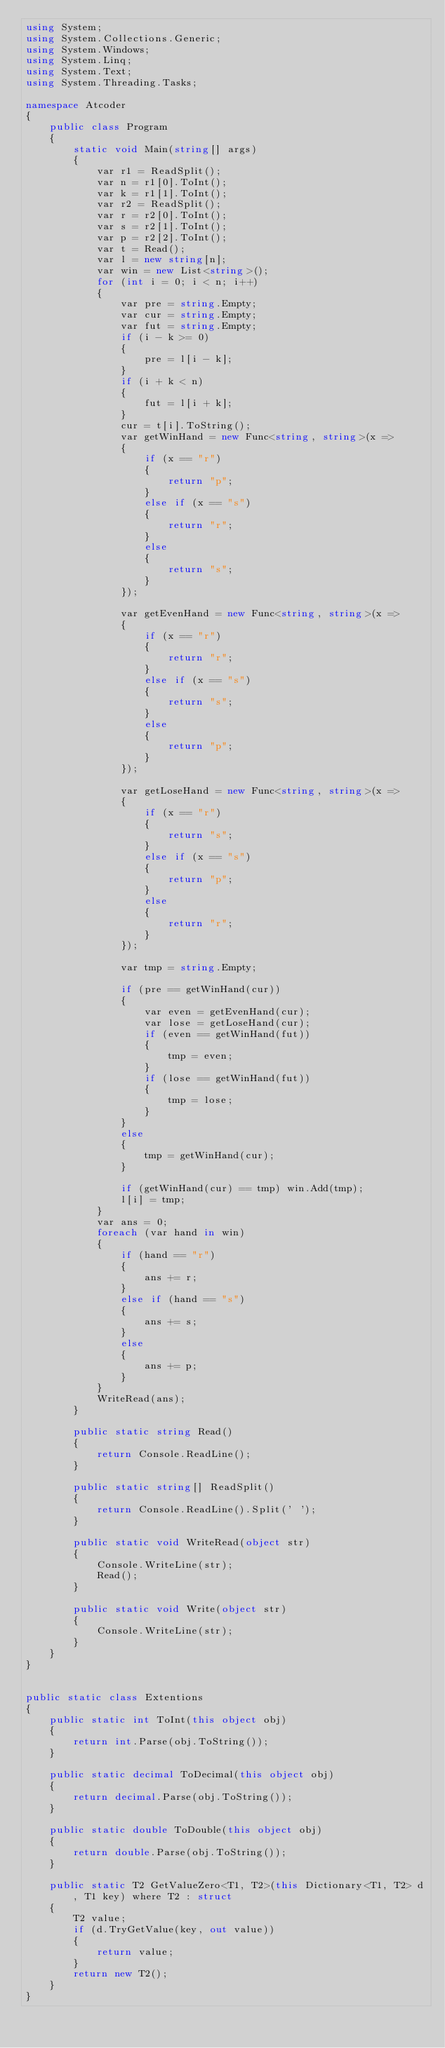<code> <loc_0><loc_0><loc_500><loc_500><_C#_>using System;
using System.Collections.Generic;
using System.Windows;
using System.Linq;
using System.Text;
using System.Threading.Tasks;

namespace Atcoder
{
    public class Program
    {
        static void Main(string[] args)
        {
            var r1 = ReadSplit();
            var n = r1[0].ToInt();
            var k = r1[1].ToInt();
            var r2 = ReadSplit();
            var r = r2[0].ToInt();
            var s = r2[1].ToInt();
            var p = r2[2].ToInt();
            var t = Read();
            var l = new string[n];
            var win = new List<string>();
            for (int i = 0; i < n; i++)
            {
                var pre = string.Empty;
                var cur = string.Empty;
                var fut = string.Empty;
                if (i - k >= 0)
                {
                    pre = l[i - k];
                }
                if (i + k < n)
                {
                    fut = l[i + k];
                }
                cur = t[i].ToString();
                var getWinHand = new Func<string, string>(x =>
                {
                    if (x == "r")
                    {
                        return "p";
                    }
                    else if (x == "s")
                    {
                        return "r";
                    }
                    else
                    {
                        return "s";
                    }
                });

                var getEvenHand = new Func<string, string>(x =>
                {
                    if (x == "r")
                    {
                        return "r";
                    }
                    else if (x == "s")
                    {
                        return "s";
                    }
                    else
                    {
                        return "p";
                    }
                });

                var getLoseHand = new Func<string, string>(x =>
                {
                    if (x == "r")
                    {
                        return "s";
                    }
                    else if (x == "s")
                    {
                        return "p";
                    }
                    else
                    {
                        return "r";
                    }
                });

                var tmp = string.Empty;

                if (pre == getWinHand(cur))
                {
                    var even = getEvenHand(cur);
                    var lose = getLoseHand(cur);
                    if (even == getWinHand(fut))
                    {
                        tmp = even;
                    }
                    if (lose == getWinHand(fut))
                    {
                        tmp = lose;
                    }
                }
                else
                {
                    tmp = getWinHand(cur);
                }

                if (getWinHand(cur) == tmp) win.Add(tmp);
                l[i] = tmp;
            }
            var ans = 0;
            foreach (var hand in win)
            {
                if (hand == "r")
                {
                    ans += r;
                }
                else if (hand == "s")
                {
                    ans += s;
                }
                else
                {
                    ans += p;
                }
            }
            WriteRead(ans);
        }

        public static string Read()
        {
            return Console.ReadLine();
        }

        public static string[] ReadSplit()
        {
            return Console.ReadLine().Split(' ');
        }

        public static void WriteRead(object str)
        {
            Console.WriteLine(str);
            Read();
        }

        public static void Write(object str)
        {
            Console.WriteLine(str);
        }
    }
}


public static class Extentions
{
    public static int ToInt(this object obj)
    {
        return int.Parse(obj.ToString());
    }

    public static decimal ToDecimal(this object obj)
    {
        return decimal.Parse(obj.ToString());
    }

    public static double ToDouble(this object obj)
    {
        return double.Parse(obj.ToString());
    }

    public static T2 GetValueZero<T1, T2>(this Dictionary<T1, T2> d, T1 key) where T2 : struct
    {
        T2 value;
        if (d.TryGetValue(key, out value))
        {
            return value;
        }
        return new T2();
    }
}

</code> 